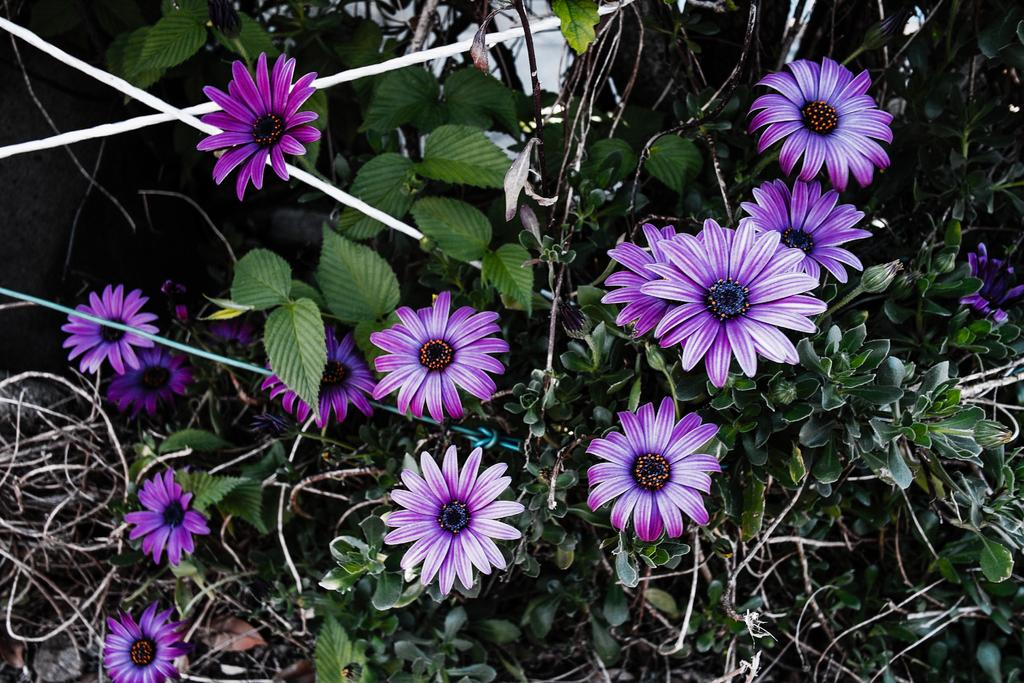What type of plants can be seen in the image? There are flowers in the image. What color are the flowers? The flowers are purple. What else can be seen in the image besides the flowers? There are leaves in the image. What color are the leaves? The leaves are green. What type of wine is being served at the property in the image? There is no wine or property present in the image; it features flowers and leaves. What fictional character can be seen interacting with the flowers in the image? There are no fictional characters present in the image; it features flowers and leaves. 